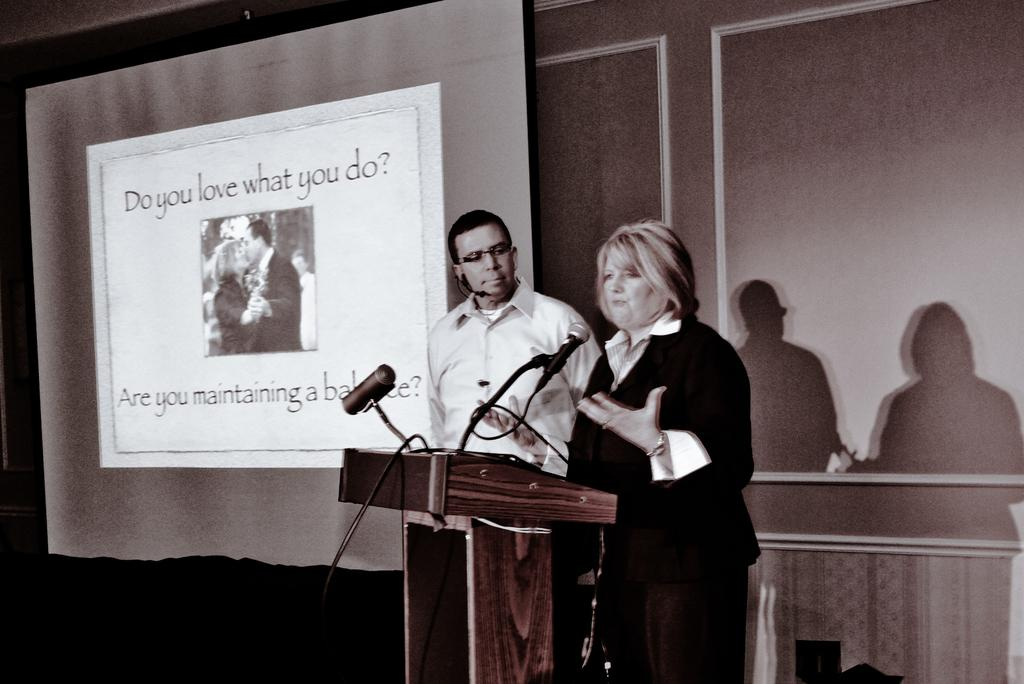How many people are in the image? There is a lady and a man in the image. What is the man wearing that helps him see better? The man is wearing glasses (specs) in the image. What is the man holding in his hand? The man is holding a microphone (mic) in the image. What is in front of the lady? There is a podium in front of the lady. What is on the podium? The podium has a microphone and a microphone stand on it. What can be seen on the wall in the background? There is a screen on the wall in the background. What is the effect of the self on the day in the image? There is no mention of a self or a day in the image, so this question cannot be answered. 